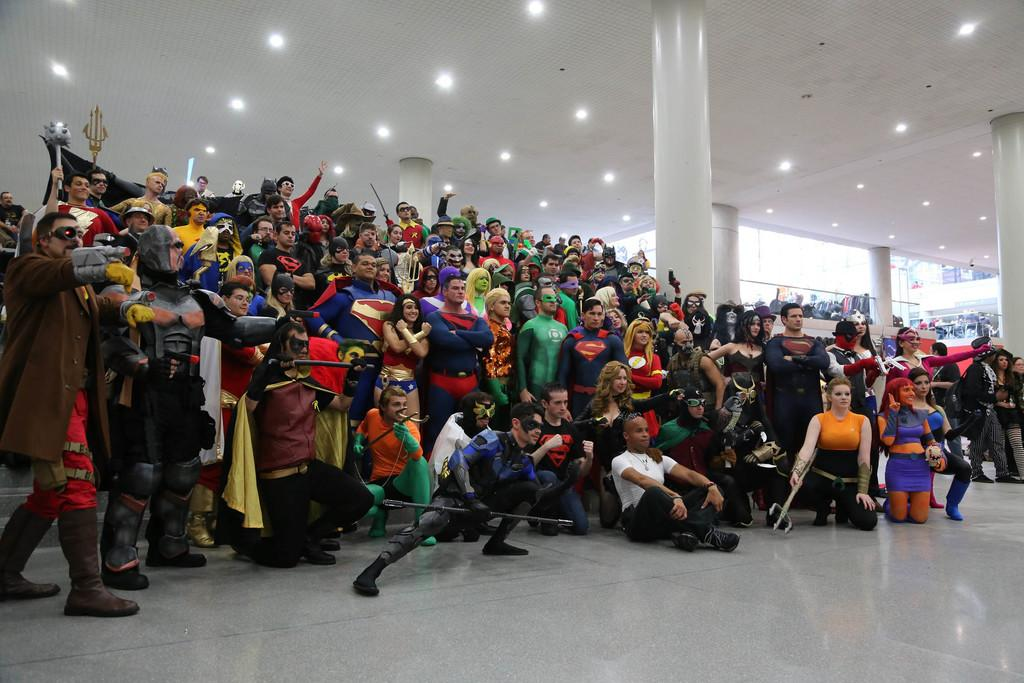How many people are in the image? There is a group of persons in the image. What are the people wearing in the image? The persons are dressed in costumes. Where are the people standing in the image? The persons are standing on the floor. What can be seen in the background of the image? There are electric lights and grills in the background of the image. What type of rock is being used as a letter opener in the image? There is no rock or letter opener present in the image. 